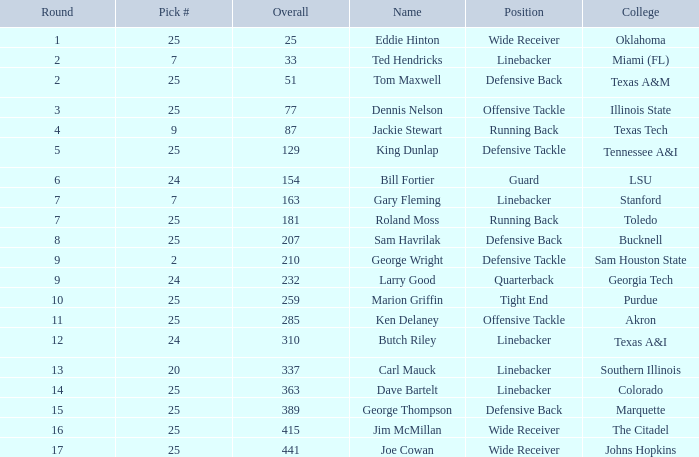What is the designation for a choice of 25 within a total of 207? Sam Havrilak. 